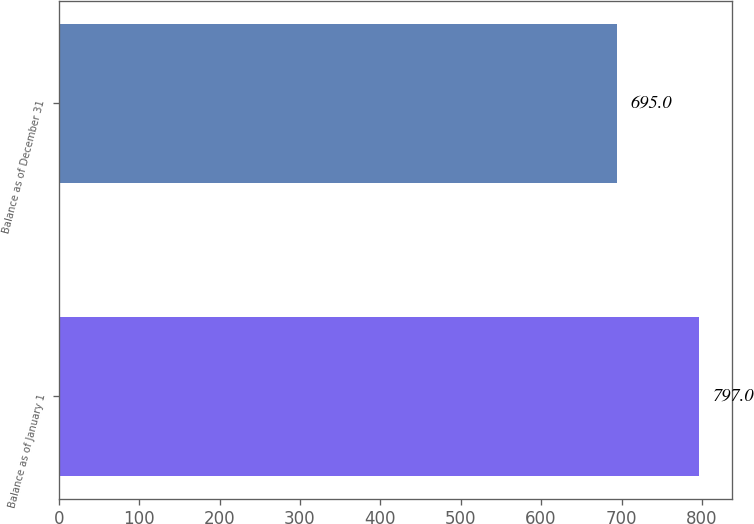Convert chart. <chart><loc_0><loc_0><loc_500><loc_500><bar_chart><fcel>Balance as of January 1<fcel>Balance as of December 31<nl><fcel>797<fcel>695<nl></chart> 